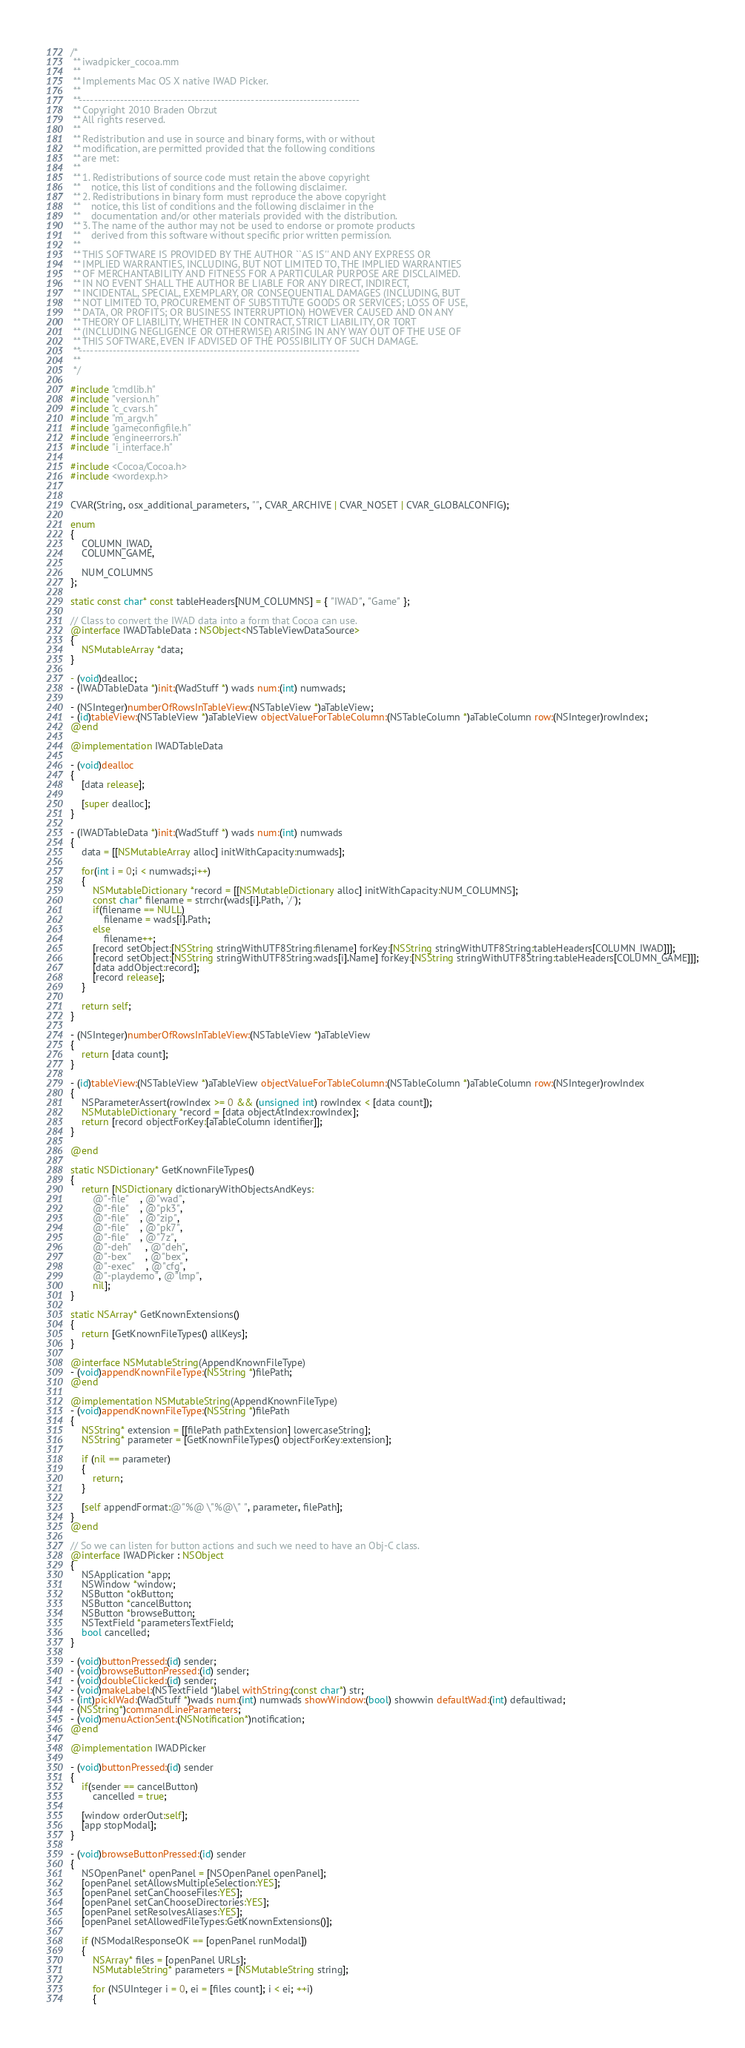Convert code to text. <code><loc_0><loc_0><loc_500><loc_500><_ObjectiveC_>/*
 ** iwadpicker_cocoa.mm
 **
 ** Implements Mac OS X native IWAD Picker.
 **
 **---------------------------------------------------------------------------
 ** Copyright 2010 Braden Obrzut
 ** All rights reserved.
 **
 ** Redistribution and use in source and binary forms, with or without
 ** modification, are permitted provided that the following conditions
 ** are met:
 **
 ** 1. Redistributions of source code must retain the above copyright
 **    notice, this list of conditions and the following disclaimer.
 ** 2. Redistributions in binary form must reproduce the above copyright
 **    notice, this list of conditions and the following disclaimer in the
 **    documentation and/or other materials provided with the distribution.
 ** 3. The name of the author may not be used to endorse or promote products
 **    derived from this software without specific prior written permission.
 **
 ** THIS SOFTWARE IS PROVIDED BY THE AUTHOR ``AS IS'' AND ANY EXPRESS OR
 ** IMPLIED WARRANTIES, INCLUDING, BUT NOT LIMITED TO, THE IMPLIED WARRANTIES
 ** OF MERCHANTABILITY AND FITNESS FOR A PARTICULAR PURPOSE ARE DISCLAIMED.
 ** IN NO EVENT SHALL THE AUTHOR BE LIABLE FOR ANY DIRECT, INDIRECT,
 ** INCIDENTAL, SPECIAL, EXEMPLARY, OR CONSEQUENTIAL DAMAGES (INCLUDING, BUT
 ** NOT LIMITED TO, PROCUREMENT OF SUBSTITUTE GOODS OR SERVICES; LOSS OF USE,
 ** DATA, OR PROFITS; OR BUSINESS INTERRUPTION) HOWEVER CAUSED AND ON ANY
 ** THEORY OF LIABILITY, WHETHER IN CONTRACT, STRICT LIABILITY, OR TORT
 ** (INCLUDING NEGLIGENCE OR OTHERWISE) ARISING IN ANY WAY OUT OF THE USE OF
 ** THIS SOFTWARE, EVEN IF ADVISED OF THE POSSIBILITY OF SUCH DAMAGE.
 **---------------------------------------------------------------------------
 **
 */

#include "cmdlib.h"
#include "version.h"
#include "c_cvars.h"
#include "m_argv.h"
#include "gameconfigfile.h"
#include "engineerrors.h"
#include "i_interface.h"

#include <Cocoa/Cocoa.h>
#include <wordexp.h>


CVAR(String, osx_additional_parameters, "", CVAR_ARCHIVE | CVAR_NOSET | CVAR_GLOBALCONFIG);

enum
{
	COLUMN_IWAD,
	COLUMN_GAME,

	NUM_COLUMNS
};

static const char* const tableHeaders[NUM_COLUMNS] = { "IWAD", "Game" };

// Class to convert the IWAD data into a form that Cocoa can use.
@interface IWADTableData : NSObject<NSTableViewDataSource>
{
	NSMutableArray *data;
}

- (void)dealloc;
- (IWADTableData *)init:(WadStuff *) wads num:(int) numwads;

- (NSInteger)numberOfRowsInTableView:(NSTableView *)aTableView;
- (id)tableView:(NSTableView *)aTableView objectValueForTableColumn:(NSTableColumn *)aTableColumn row:(NSInteger)rowIndex;
@end

@implementation IWADTableData

- (void)dealloc
{
	[data release];

	[super dealloc];
}

- (IWADTableData *)init:(WadStuff *) wads num:(int) numwads
{
	data = [[NSMutableArray alloc] initWithCapacity:numwads];

	for(int i = 0;i < numwads;i++)
	{
		NSMutableDictionary *record = [[NSMutableDictionary alloc] initWithCapacity:NUM_COLUMNS];
		const char* filename = strrchr(wads[i].Path, '/');
		if(filename == NULL)
			filename = wads[i].Path;
		else
			filename++;
		[record setObject:[NSString stringWithUTF8String:filename] forKey:[NSString stringWithUTF8String:tableHeaders[COLUMN_IWAD]]];
		[record setObject:[NSString stringWithUTF8String:wads[i].Name] forKey:[NSString stringWithUTF8String:tableHeaders[COLUMN_GAME]]];
		[data addObject:record];
		[record release];
	}

	return self;
}

- (NSInteger)numberOfRowsInTableView:(NSTableView *)aTableView
{
	return [data count];
}

- (id)tableView:(NSTableView *)aTableView objectValueForTableColumn:(NSTableColumn *)aTableColumn row:(NSInteger)rowIndex
{
	NSParameterAssert(rowIndex >= 0 && (unsigned int) rowIndex < [data count]);
	NSMutableDictionary *record = [data objectAtIndex:rowIndex];
	return [record objectForKey:[aTableColumn identifier]];
}

@end

static NSDictionary* GetKnownFileTypes()
{
	return [NSDictionary dictionaryWithObjectsAndKeys:
		@"-file"    , @"wad",
		@"-file"    , @"pk3",
		@"-file"    , @"zip",
		@"-file"    , @"pk7",
		@"-file"    , @"7z",
		@"-deh"     , @"deh",
		@"-bex"     , @"bex",
		@"-exec"    , @"cfg",
		@"-playdemo", @"lmp",
		nil];
}

static NSArray* GetKnownExtensions()
{
	return [GetKnownFileTypes() allKeys];
}

@interface NSMutableString(AppendKnownFileType)
- (void)appendKnownFileType:(NSString *)filePath;
@end

@implementation NSMutableString(AppendKnownFileType)
- (void)appendKnownFileType:(NSString *)filePath
{
	NSString* extension = [[filePath pathExtension] lowercaseString];
	NSString* parameter = [GetKnownFileTypes() objectForKey:extension];

	if (nil == parameter)
	{
		return;
	}

	[self appendFormat:@"%@ \"%@\" ", parameter, filePath];
}
@end

// So we can listen for button actions and such we need to have an Obj-C class.
@interface IWADPicker : NSObject
{
	NSApplication *app;
	NSWindow *window;
	NSButton *okButton;
	NSButton *cancelButton;
	NSButton *browseButton;
	NSTextField *parametersTextField;
	bool cancelled;
}

- (void)buttonPressed:(id) sender;
- (void)browseButtonPressed:(id) sender;
- (void)doubleClicked:(id) sender;
- (void)makeLabel:(NSTextField *)label withString:(const char*) str;
- (int)pickIWad:(WadStuff *)wads num:(int) numwads showWindow:(bool) showwin defaultWad:(int) defaultiwad;
- (NSString*)commandLineParameters;
- (void)menuActionSent:(NSNotification*)notification;
@end

@implementation IWADPicker

- (void)buttonPressed:(id) sender
{
	if(sender == cancelButton)
		cancelled = true;

	[window orderOut:self];
	[app stopModal];
}

- (void)browseButtonPressed:(id) sender
{
	NSOpenPanel* openPanel = [NSOpenPanel openPanel];
	[openPanel setAllowsMultipleSelection:YES];
	[openPanel setCanChooseFiles:YES];
	[openPanel setCanChooseDirectories:YES];
	[openPanel setResolvesAliases:YES];
	[openPanel setAllowedFileTypes:GetKnownExtensions()];

	if (NSModalResponseOK == [openPanel runModal])
	{
		NSArray* files = [openPanel URLs];
		NSMutableString* parameters = [NSMutableString string];

		for (NSUInteger i = 0, ei = [files count]; i < ei; ++i)
		{</code> 